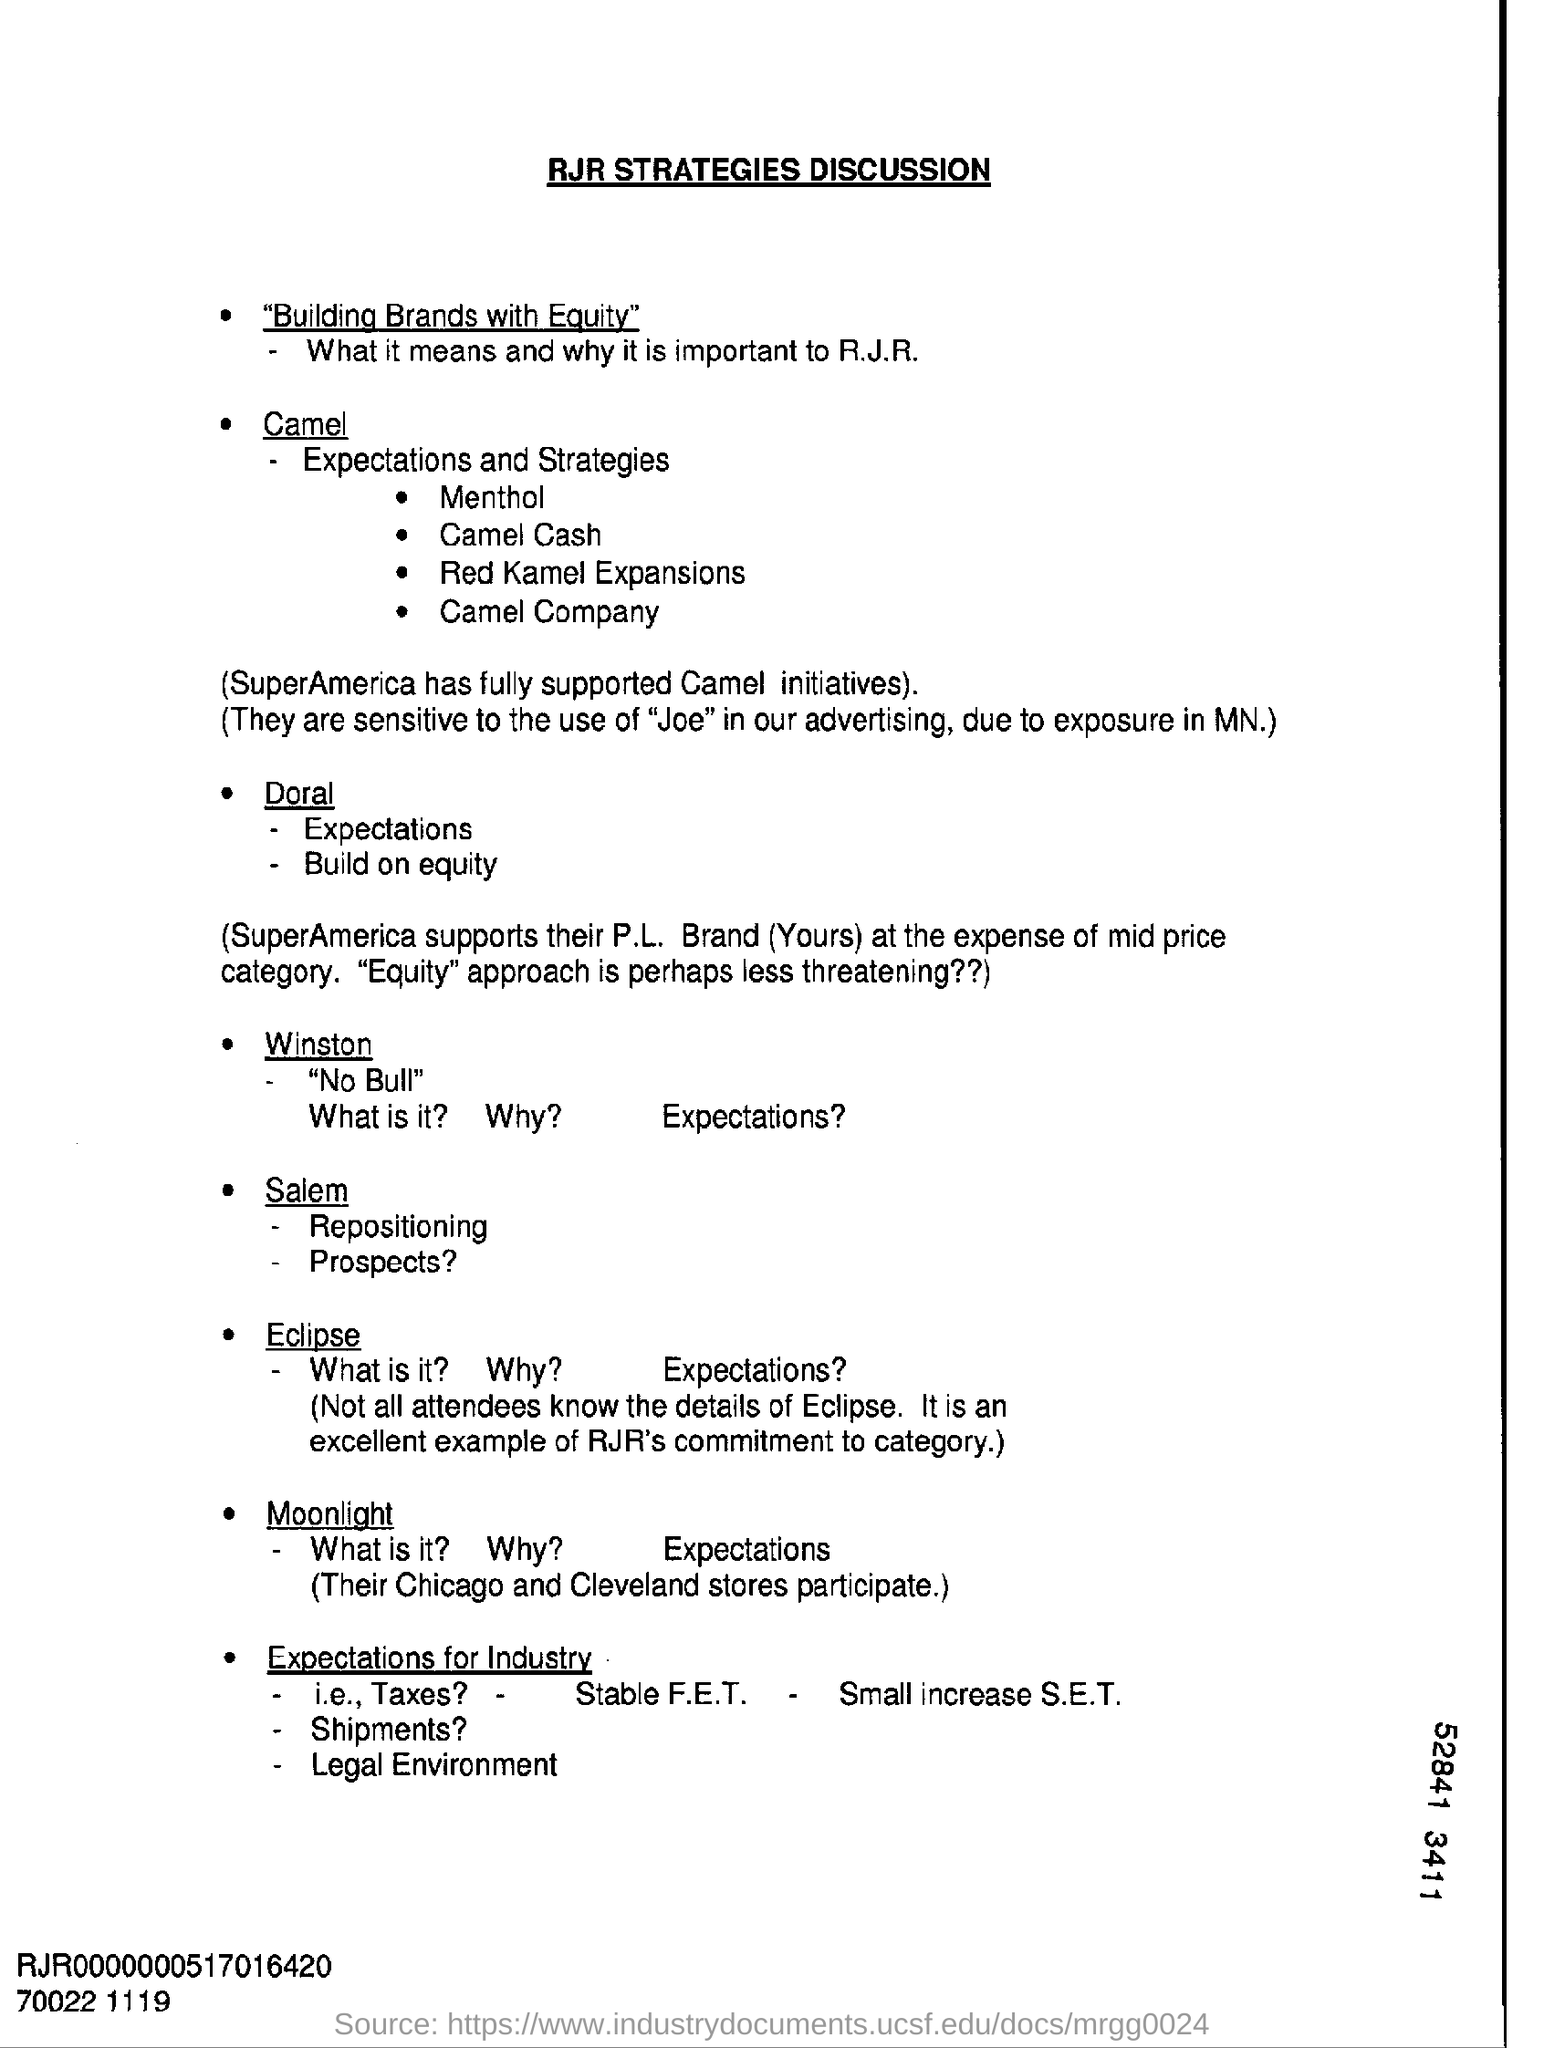Outline some significant characteristics in this image. The heading at the top of the page is 'RJR Strategies Discussion.' 